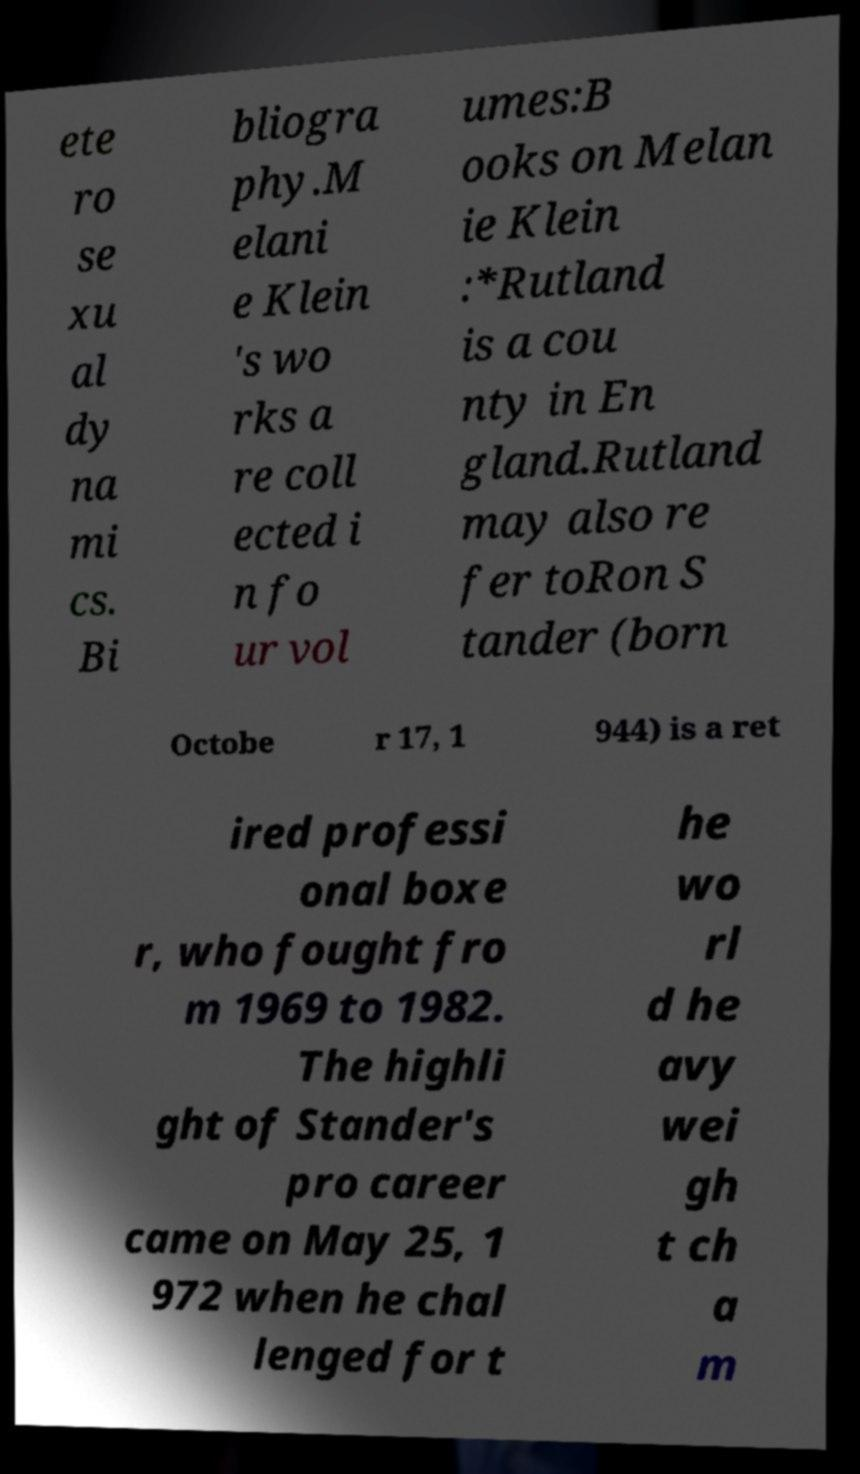Please identify and transcribe the text found in this image. ete ro se xu al dy na mi cs. Bi bliogra phy.M elani e Klein 's wo rks a re coll ected i n fo ur vol umes:B ooks on Melan ie Klein :*Rutland is a cou nty in En gland.Rutland may also re fer toRon S tander (born Octobe r 17, 1 944) is a ret ired professi onal boxe r, who fought fro m 1969 to 1982. The highli ght of Stander's pro career came on May 25, 1 972 when he chal lenged for t he wo rl d he avy wei gh t ch a m 